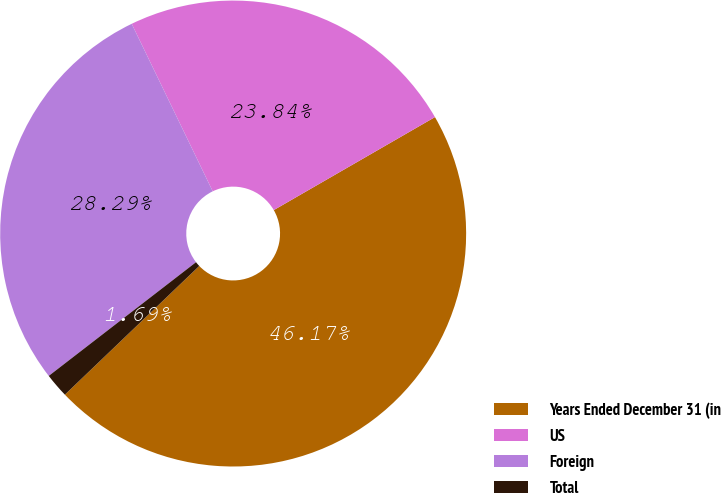Convert chart to OTSL. <chart><loc_0><loc_0><loc_500><loc_500><pie_chart><fcel>Years Ended December 31 (in<fcel>US<fcel>Foreign<fcel>Total<nl><fcel>46.17%<fcel>23.84%<fcel>28.29%<fcel>1.69%<nl></chart> 